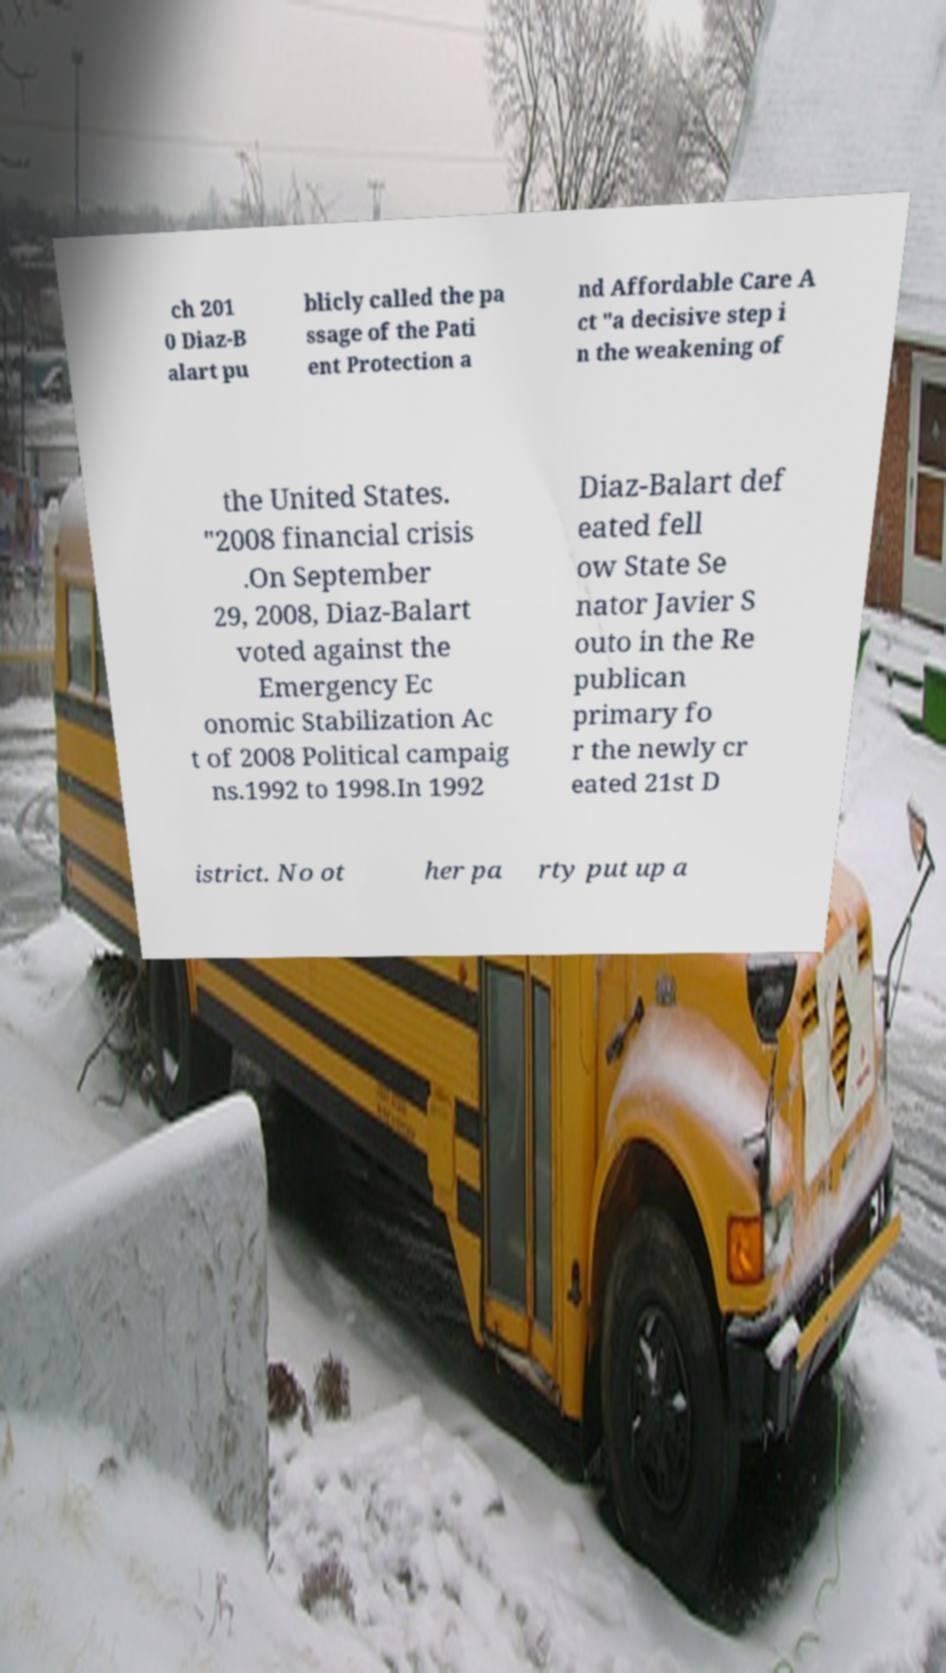Can you read and provide the text displayed in the image?This photo seems to have some interesting text. Can you extract and type it out for me? ch 201 0 Diaz-B alart pu blicly called the pa ssage of the Pati ent Protection a nd Affordable Care A ct "a decisive step i n the weakening of the United States. "2008 financial crisis .On September 29, 2008, Diaz-Balart voted against the Emergency Ec onomic Stabilization Ac t of 2008 Political campaig ns.1992 to 1998.In 1992 Diaz-Balart def eated fell ow State Se nator Javier S outo in the Re publican primary fo r the newly cr eated 21st D istrict. No ot her pa rty put up a 